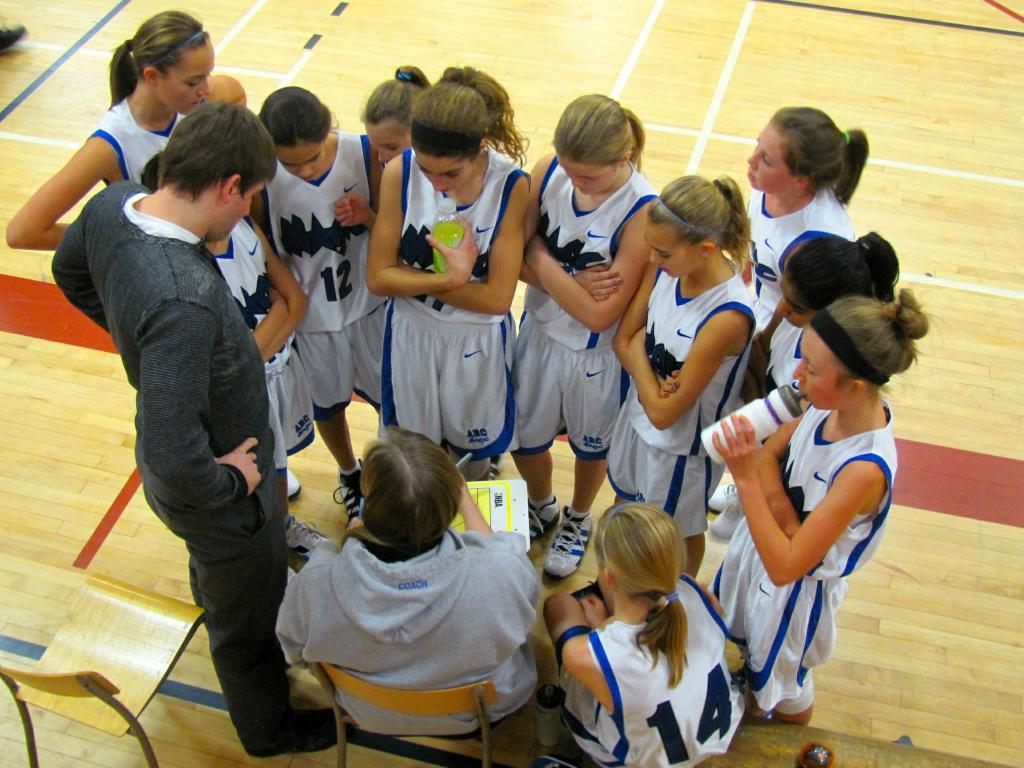<image>
Offer a succinct explanation of the picture presented. A girl in a number 14 basketball jersey huddles up with her team. 